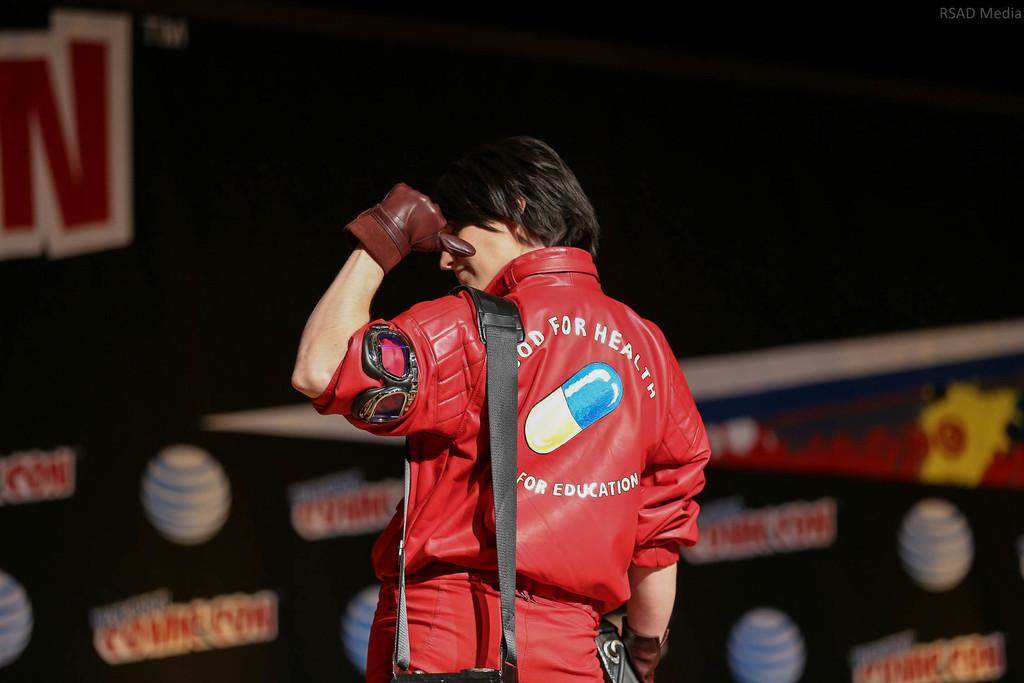<image>
Present a compact description of the photo's key features. A man wearing a red jacket which has Good For Health on its back. 